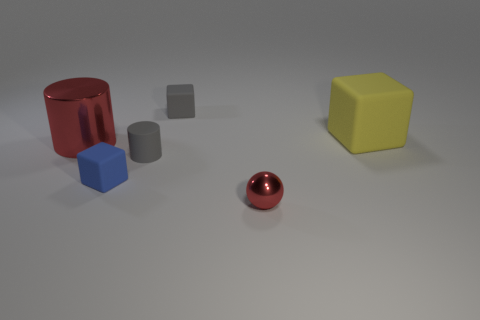Subtract all gray rubber cubes. How many cubes are left? 2 Add 4 gray cylinders. How many objects exist? 10 Subtract all gray cubes. How many cubes are left? 2 Subtract 2 blocks. How many blocks are left? 1 Subtract all cyan cubes. Subtract all purple cylinders. How many cubes are left? 3 Subtract all brown spheres. How many red cylinders are left? 1 Subtract all red balls. Subtract all large red metallic things. How many objects are left? 4 Add 3 tiny gray cylinders. How many tiny gray cylinders are left? 4 Add 1 large purple shiny things. How many large purple shiny things exist? 1 Subtract 1 yellow blocks. How many objects are left? 5 